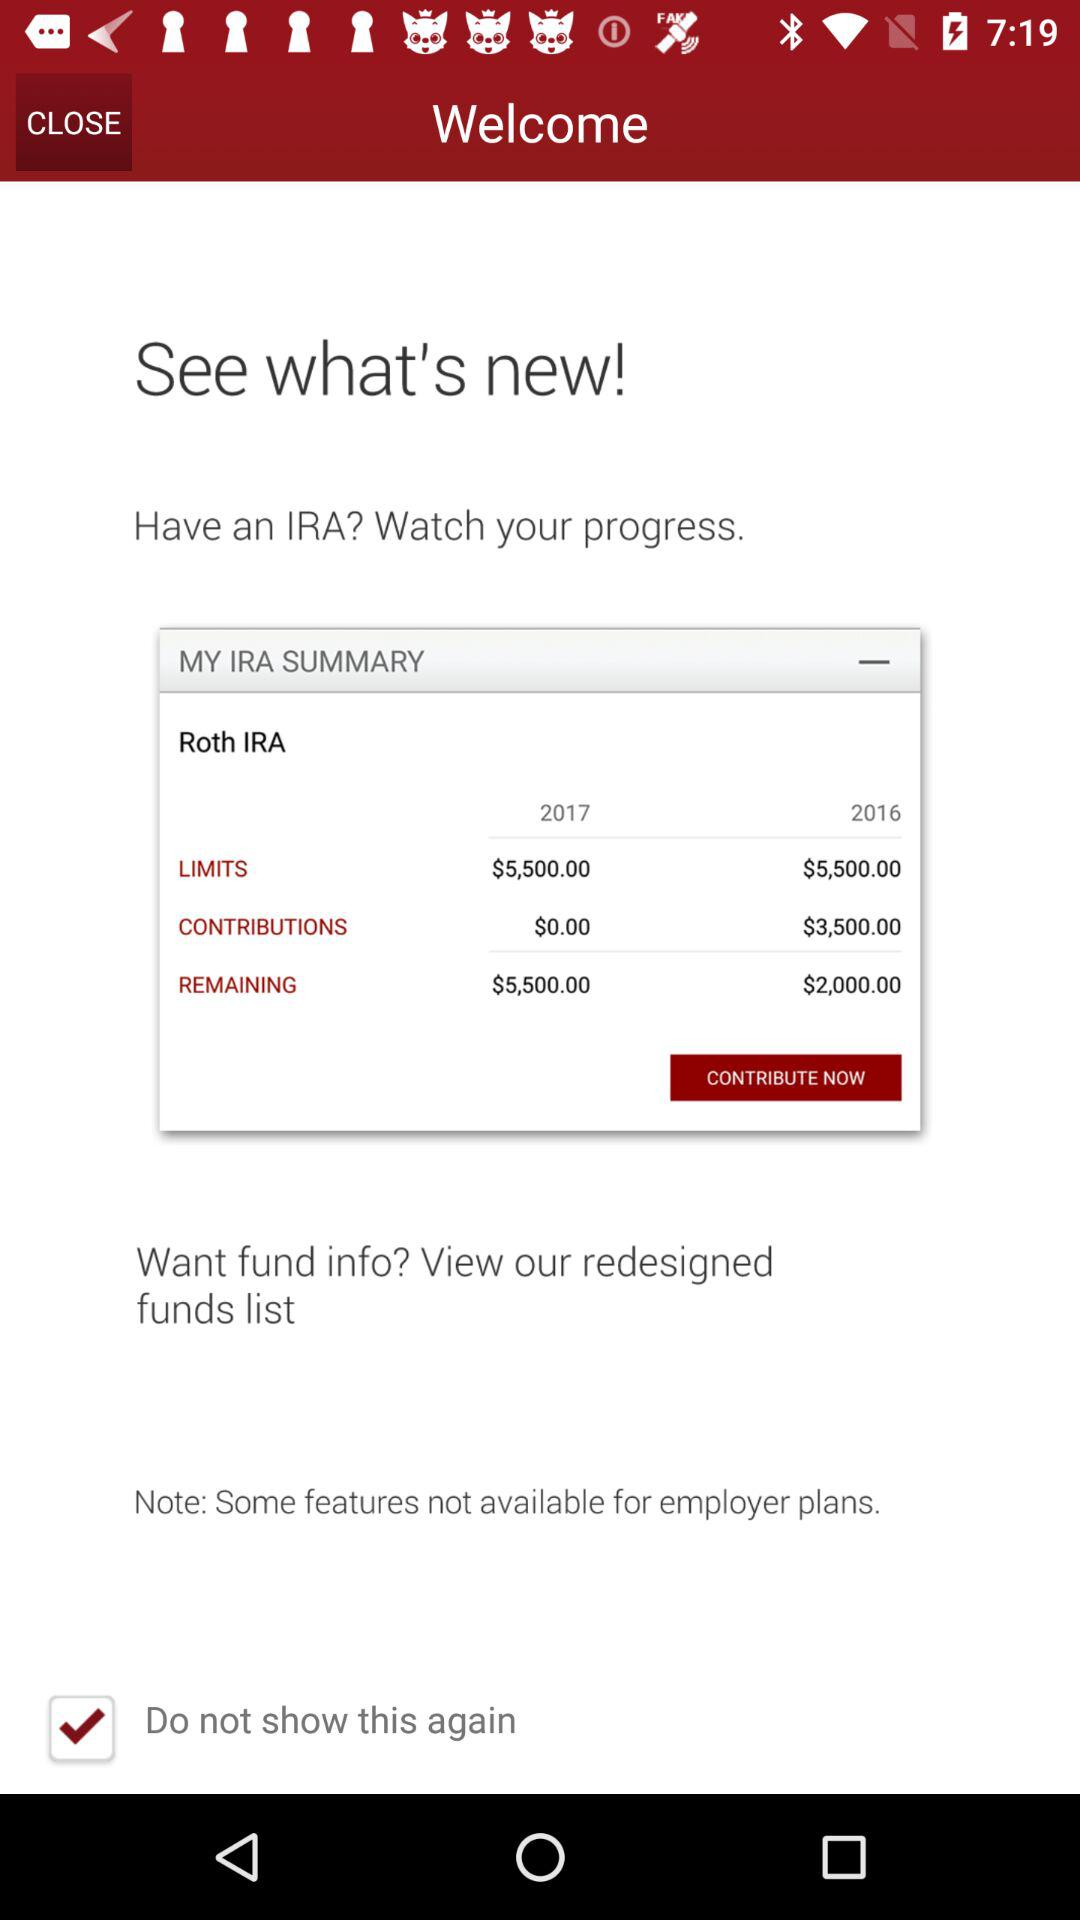What is the amount limit in 2016? The amount limit in 2016 is $5,500. 